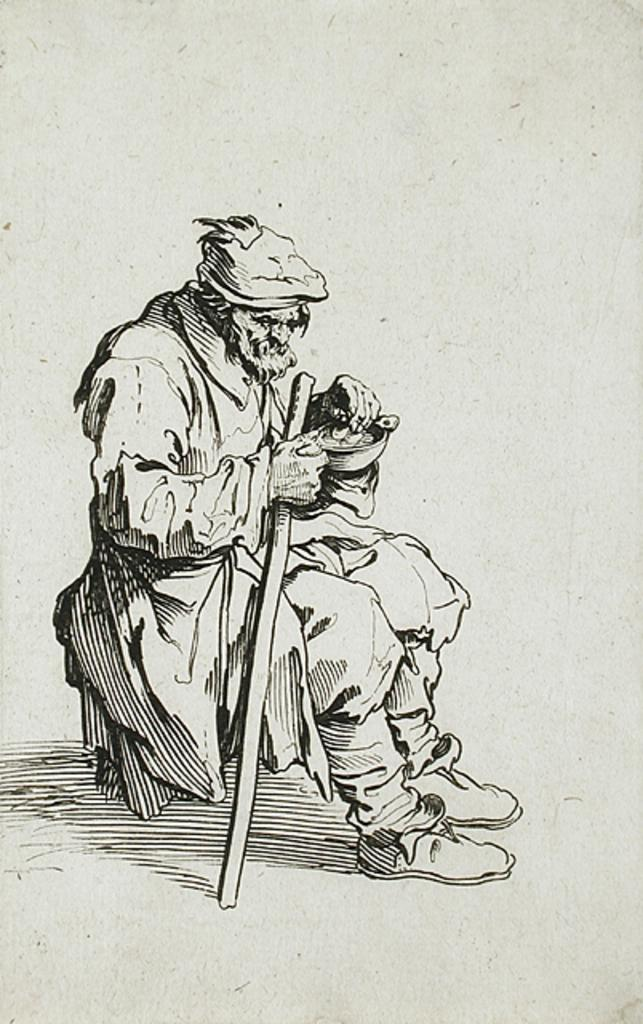What is the color scheme of the image? The image is black and white. What can be seen in the image? There is a person sitting in the image. What is the person doing in the image? The person is holding objects. What can be seen in the background of the image? There is a wall visible in the background of the image. How many ladybugs are crawling on the person's arm in the image? There are no ladybugs present in the image. What degree does the person in the image hold? The image does not provide information about the person's educational background or degrees. 